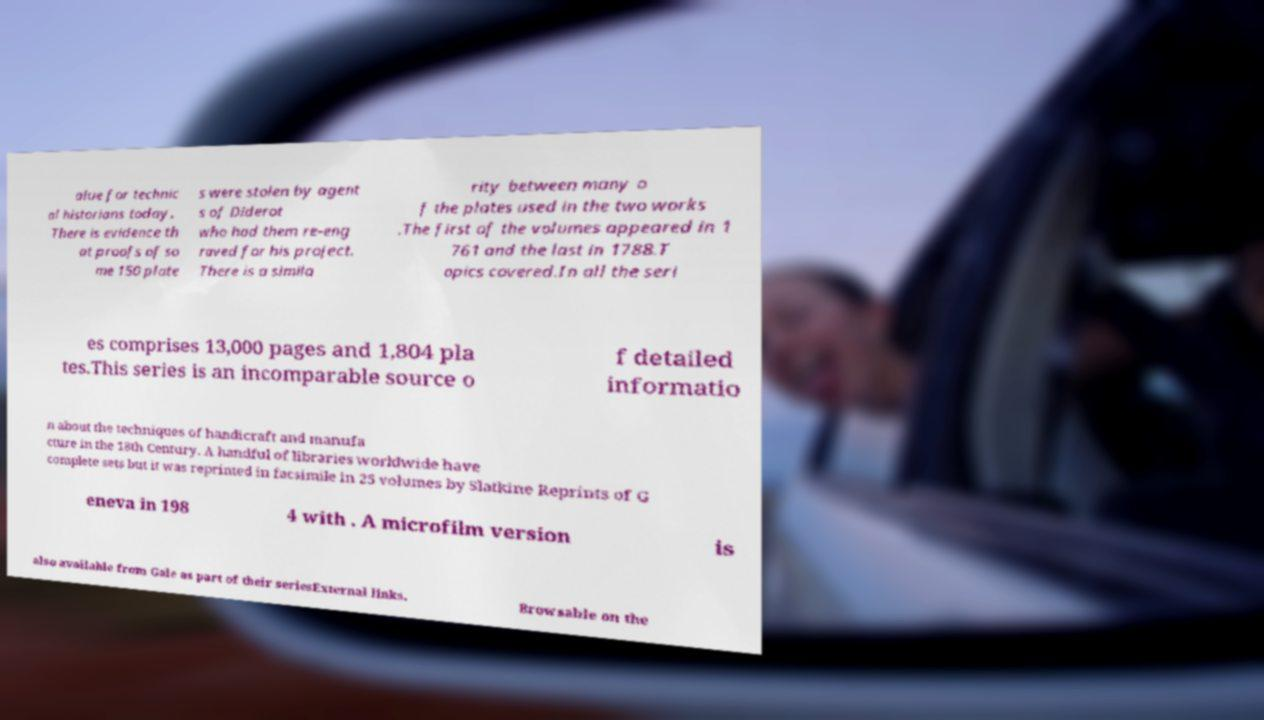There's text embedded in this image that I need extracted. Can you transcribe it verbatim? alue for technic al historians today. There is evidence th at proofs of so me 150 plate s were stolen by agent s of Diderot who had them re-eng raved for his project. There is a simila rity between many o f the plates used in the two works .The first of the volumes appeared in 1 761 and the last in 1788.T opics covered.In all the seri es comprises 13,000 pages and 1,804 pla tes.This series is an incomparable source o f detailed informatio n about the techniques of handicraft and manufa cture in the 18th Century. A handful of libraries worldwide have complete sets but it was reprinted in facsimile in 25 volumes by Slatkine Reprints of G eneva in 198 4 with . A microfilm version is also available from Gale as part of their seriesExternal links. Browsable on the 